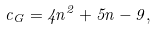<formula> <loc_0><loc_0><loc_500><loc_500>c _ { G } = 4 n ^ { 2 } + 5 n - 9 ,</formula> 